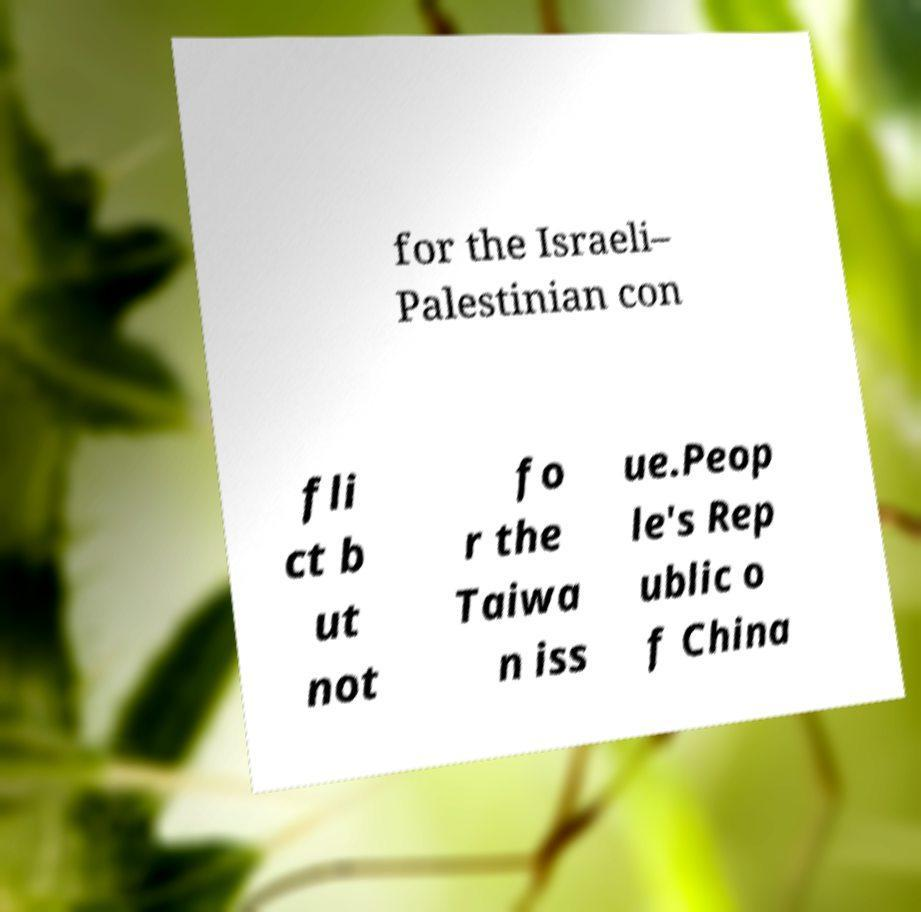Can you read and provide the text displayed in the image?This photo seems to have some interesting text. Can you extract and type it out for me? for the Israeli– Palestinian con fli ct b ut not fo r the Taiwa n iss ue.Peop le's Rep ublic o f China 